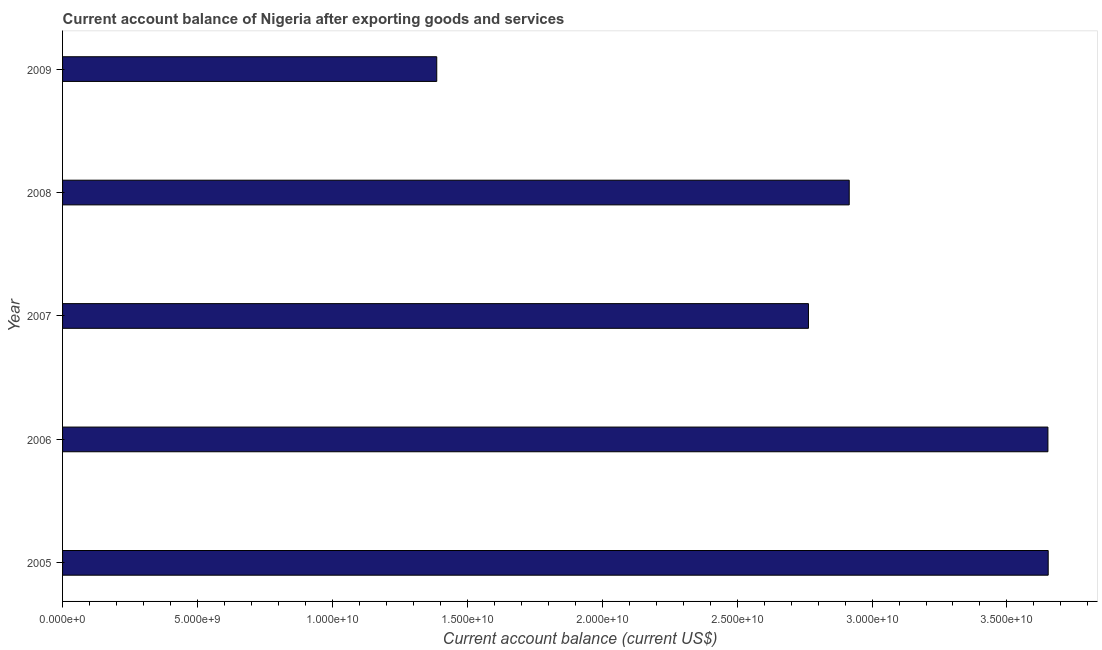Does the graph contain grids?
Provide a succinct answer. No. What is the title of the graph?
Give a very brief answer. Current account balance of Nigeria after exporting goods and services. What is the label or title of the X-axis?
Your answer should be very brief. Current account balance (current US$). What is the current account balance in 2009?
Offer a terse response. 1.39e+1. Across all years, what is the maximum current account balance?
Provide a short and direct response. 3.65e+1. Across all years, what is the minimum current account balance?
Provide a succinct answer. 1.39e+1. What is the sum of the current account balance?
Your response must be concise. 1.44e+11. What is the difference between the current account balance in 2006 and 2007?
Your answer should be very brief. 8.87e+09. What is the average current account balance per year?
Offer a terse response. 2.87e+1. What is the median current account balance?
Offer a terse response. 2.92e+1. Do a majority of the years between 2009 and 2007 (inclusive) have current account balance greater than 25000000000 US$?
Your response must be concise. Yes. What is the ratio of the current account balance in 2005 to that in 2008?
Your response must be concise. 1.25. Is the current account balance in 2006 less than that in 2008?
Provide a short and direct response. No. Is the difference between the current account balance in 2005 and 2007 greater than the difference between any two years?
Provide a succinct answer. No. What is the difference between the highest and the second highest current account balance?
Your answer should be compact. 1.10e+07. What is the difference between the highest and the lowest current account balance?
Ensure brevity in your answer.  2.27e+1. How many bars are there?
Your answer should be compact. 5. How many years are there in the graph?
Make the answer very short. 5. Are the values on the major ticks of X-axis written in scientific E-notation?
Make the answer very short. Yes. What is the Current account balance (current US$) in 2005?
Your answer should be very brief. 3.65e+1. What is the Current account balance (current US$) of 2006?
Keep it short and to the point. 3.65e+1. What is the Current account balance (current US$) in 2007?
Give a very brief answer. 2.76e+1. What is the Current account balance (current US$) of 2008?
Offer a very short reply. 2.92e+1. What is the Current account balance (current US$) in 2009?
Your response must be concise. 1.39e+1. What is the difference between the Current account balance (current US$) in 2005 and 2006?
Give a very brief answer. 1.10e+07. What is the difference between the Current account balance (current US$) in 2005 and 2007?
Offer a terse response. 8.89e+09. What is the difference between the Current account balance (current US$) in 2005 and 2008?
Your answer should be compact. 7.37e+09. What is the difference between the Current account balance (current US$) in 2005 and 2009?
Provide a short and direct response. 2.27e+1. What is the difference between the Current account balance (current US$) in 2006 and 2007?
Offer a terse response. 8.87e+09. What is the difference between the Current account balance (current US$) in 2006 and 2008?
Offer a terse response. 7.36e+09. What is the difference between the Current account balance (current US$) in 2006 and 2009?
Your answer should be very brief. 2.27e+1. What is the difference between the Current account balance (current US$) in 2007 and 2008?
Your response must be concise. -1.51e+09. What is the difference between the Current account balance (current US$) in 2007 and 2009?
Give a very brief answer. 1.38e+1. What is the difference between the Current account balance (current US$) in 2008 and 2009?
Offer a terse response. 1.53e+1. What is the ratio of the Current account balance (current US$) in 2005 to that in 2006?
Your answer should be very brief. 1. What is the ratio of the Current account balance (current US$) in 2005 to that in 2007?
Ensure brevity in your answer.  1.32. What is the ratio of the Current account balance (current US$) in 2005 to that in 2008?
Your answer should be very brief. 1.25. What is the ratio of the Current account balance (current US$) in 2005 to that in 2009?
Provide a succinct answer. 2.63. What is the ratio of the Current account balance (current US$) in 2006 to that in 2007?
Keep it short and to the point. 1.32. What is the ratio of the Current account balance (current US$) in 2006 to that in 2008?
Keep it short and to the point. 1.25. What is the ratio of the Current account balance (current US$) in 2006 to that in 2009?
Give a very brief answer. 2.63. What is the ratio of the Current account balance (current US$) in 2007 to that in 2008?
Offer a very short reply. 0.95. What is the ratio of the Current account balance (current US$) in 2007 to that in 2009?
Your answer should be very brief. 1.99. What is the ratio of the Current account balance (current US$) in 2008 to that in 2009?
Offer a very short reply. 2.1. 